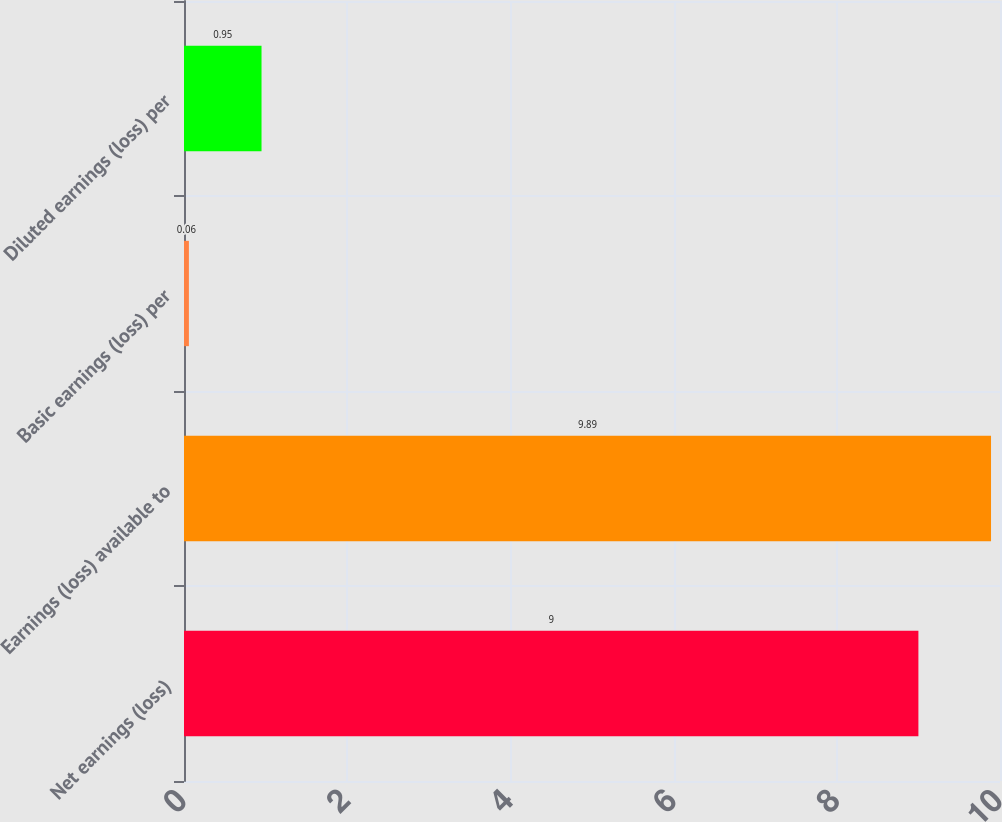Convert chart. <chart><loc_0><loc_0><loc_500><loc_500><bar_chart><fcel>Net earnings (loss)<fcel>Earnings (loss) available to<fcel>Basic earnings (loss) per<fcel>Diluted earnings (loss) per<nl><fcel>9<fcel>9.89<fcel>0.06<fcel>0.95<nl></chart> 